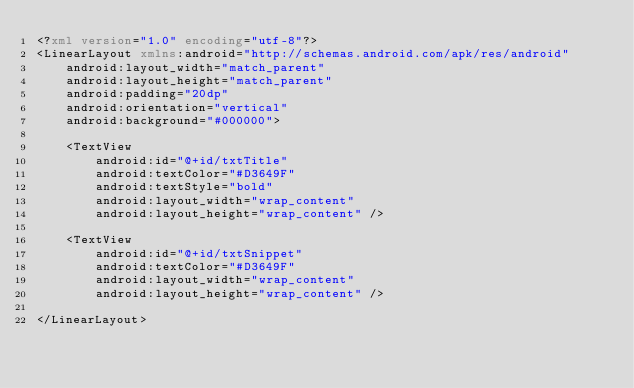Convert code to text. <code><loc_0><loc_0><loc_500><loc_500><_XML_><?xml version="1.0" encoding="utf-8"?>
<LinearLayout xmlns:android="http://schemas.android.com/apk/res/android"
    android:layout_width="match_parent"
    android:layout_height="match_parent"
    android:padding="20dp"
    android:orientation="vertical"
    android:background="#000000">

    <TextView
        android:id="@+id/txtTitle"
        android:textColor="#D3649F"
        android:textStyle="bold"
        android:layout_width="wrap_content"
        android:layout_height="wrap_content" />

    <TextView
        android:id="@+id/txtSnippet"
        android:textColor="#D3649F"
        android:layout_width="wrap_content"
        android:layout_height="wrap_content" />

</LinearLayout></code> 